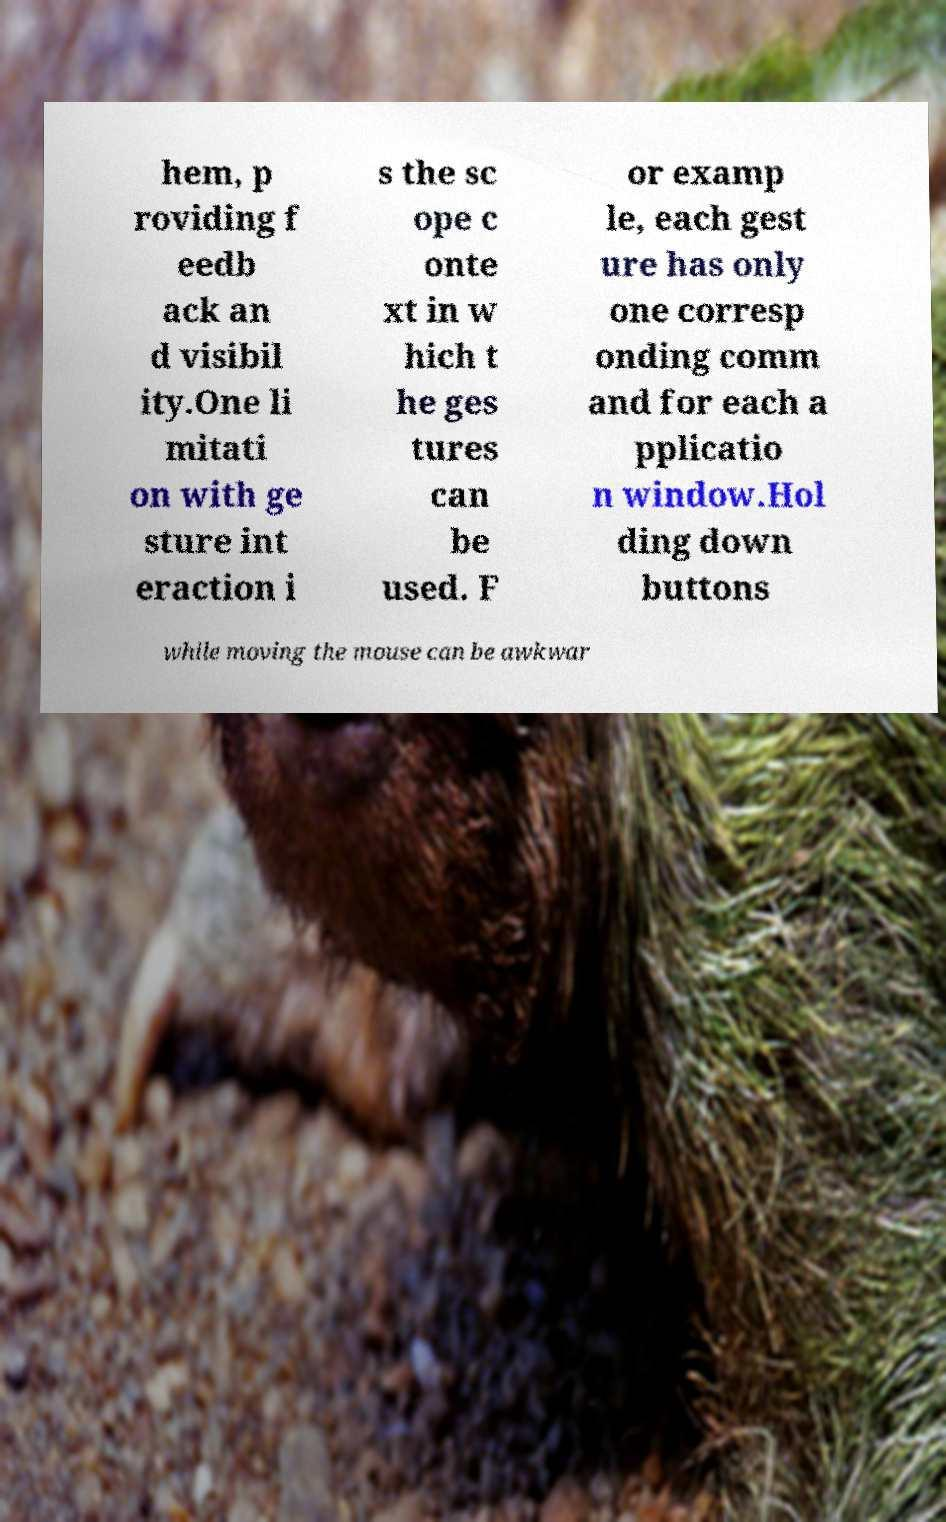There's text embedded in this image that I need extracted. Can you transcribe it verbatim? hem, p roviding f eedb ack an d visibil ity.One li mitati on with ge sture int eraction i s the sc ope c onte xt in w hich t he ges tures can be used. F or examp le, each gest ure has only one corresp onding comm and for each a pplicatio n window.Hol ding down buttons while moving the mouse can be awkwar 